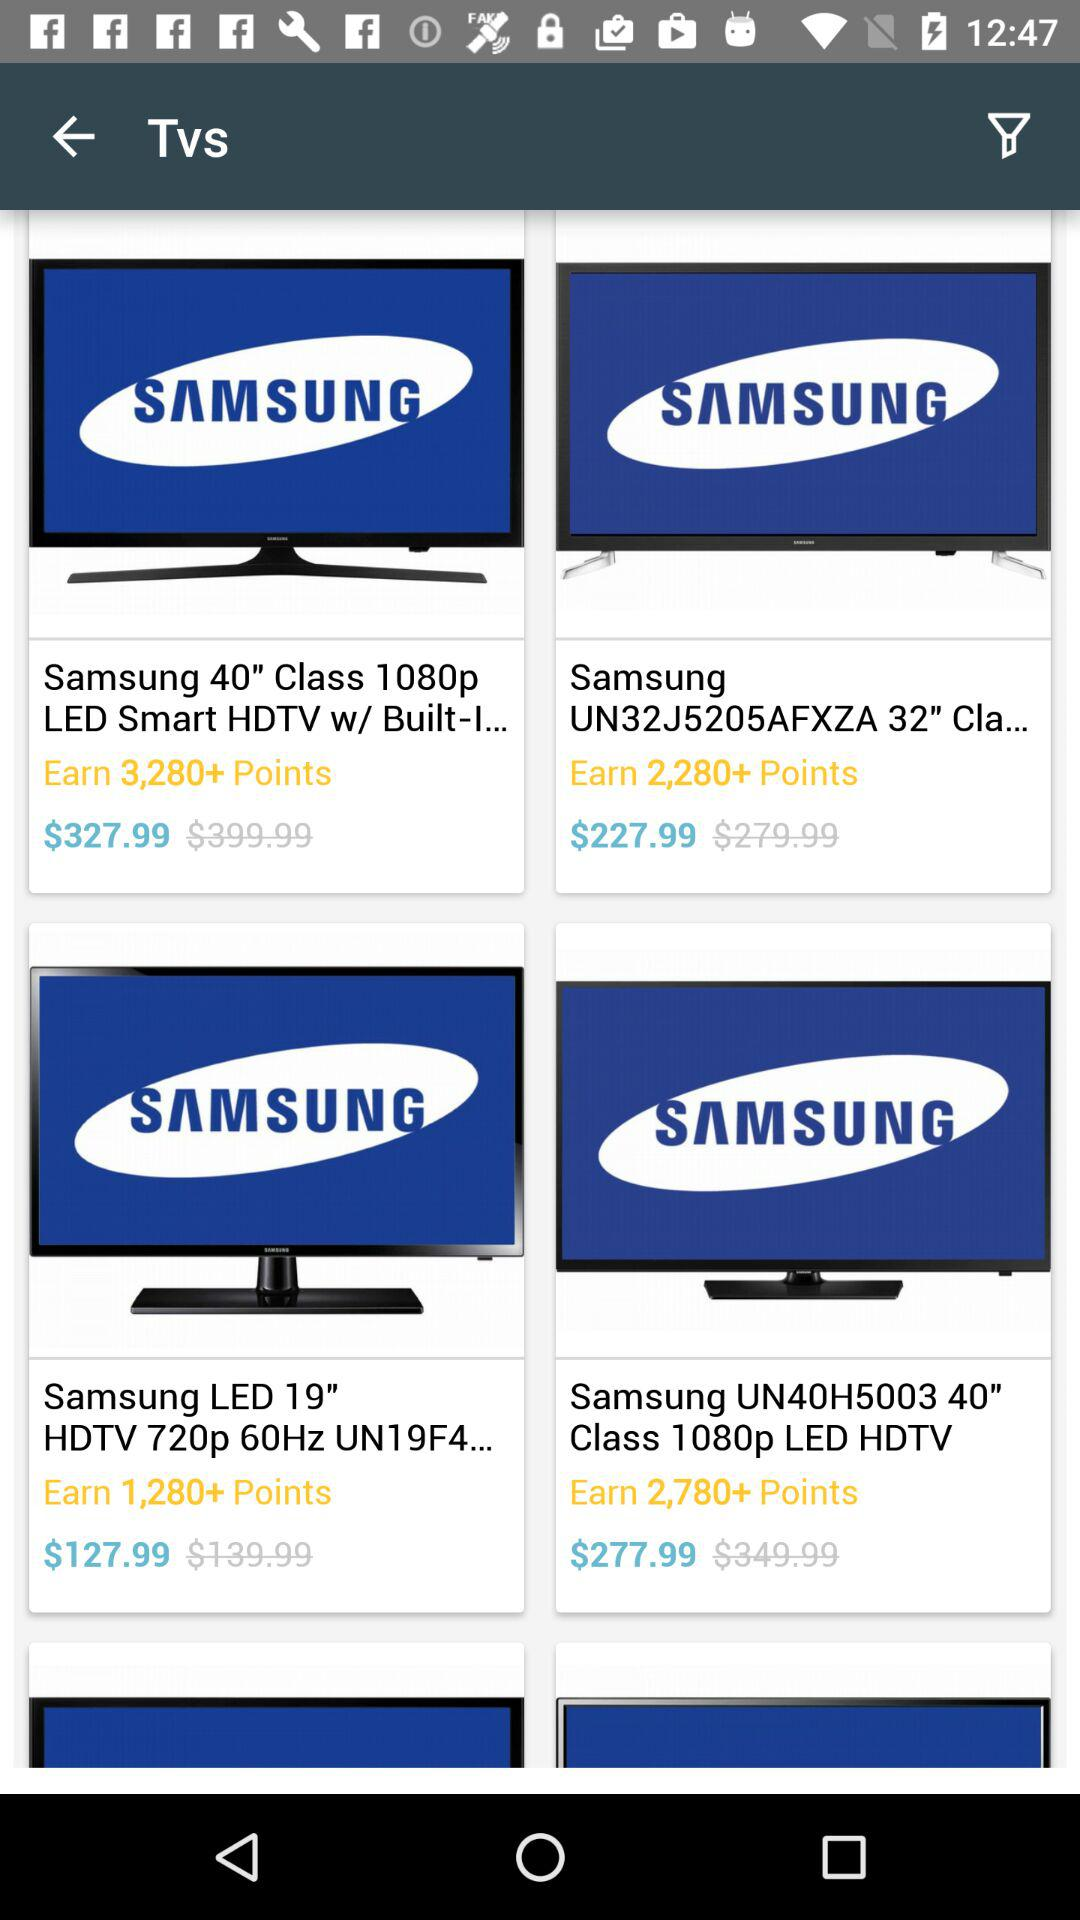What is the price of the Samsung LED 19" HDTV 720p 60Hz? The price of the Samsung LED 19" HDTV 720p 60Hz is $127.99. 